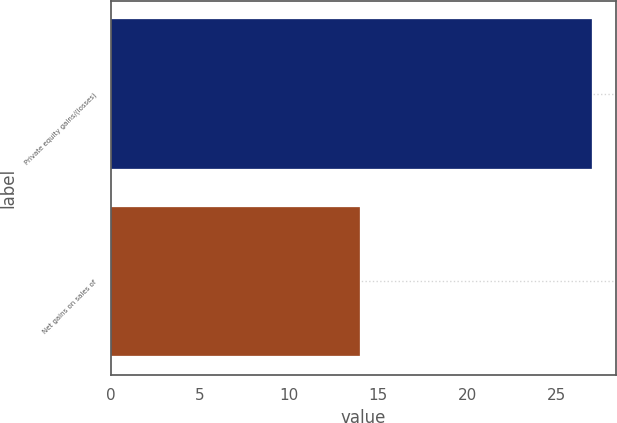Convert chart to OTSL. <chart><loc_0><loc_0><loc_500><loc_500><bar_chart><fcel>Private equity gains/(losses)<fcel>Net gains on sales of<nl><fcel>27<fcel>14<nl></chart> 